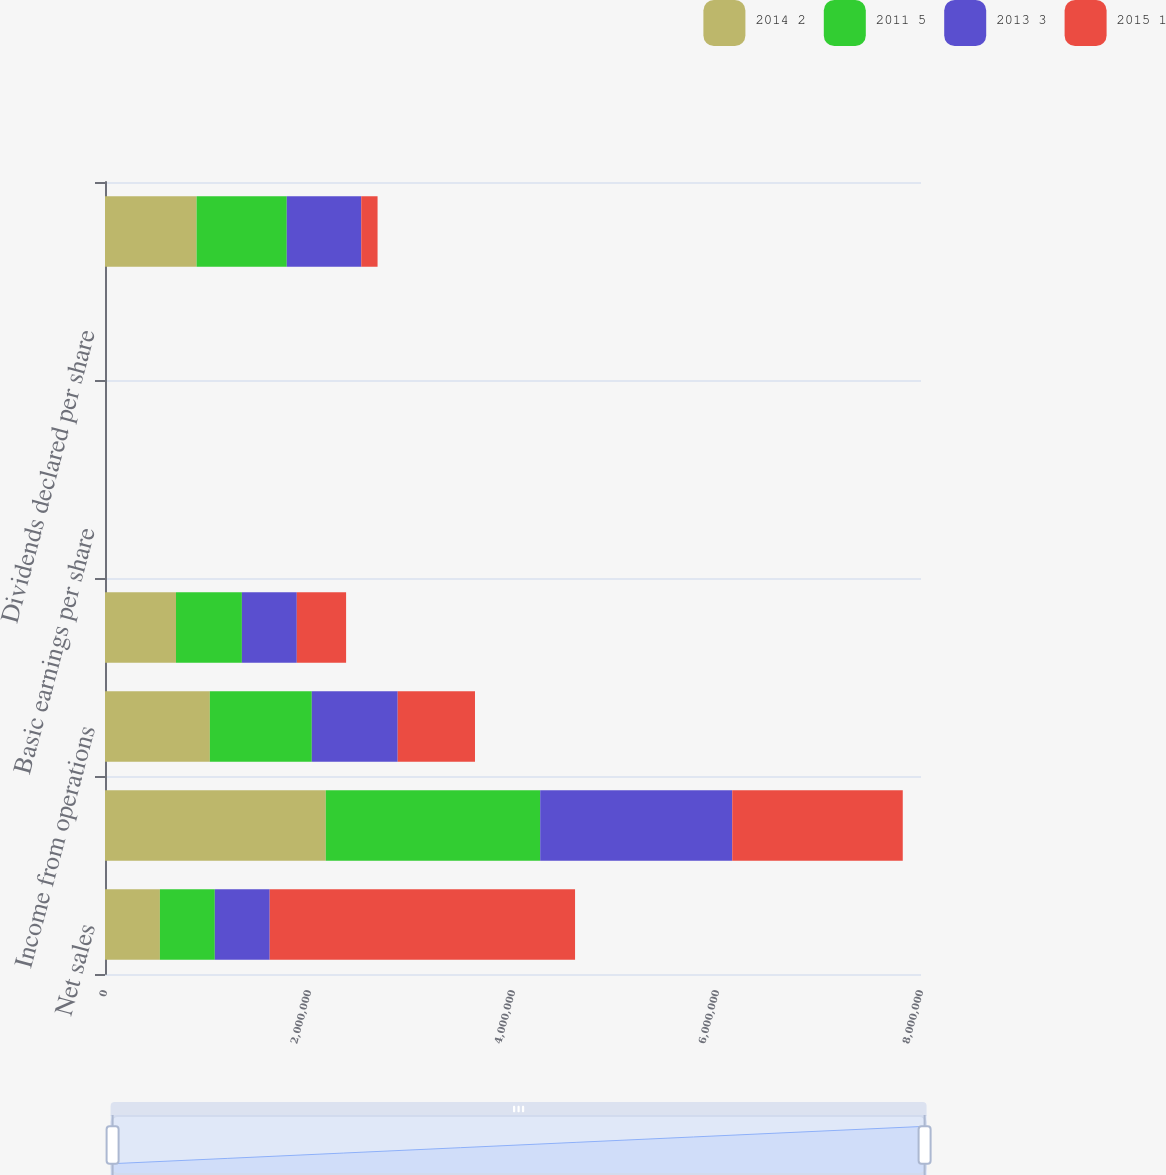Convert chart. <chart><loc_0><loc_0><loc_500><loc_500><stacked_bar_chart><ecel><fcel>Net sales<fcel>Gross profit<fcel>Income from operations<fcel>Net earnings<fcel>Basic earnings per share<fcel>Diluted earnings per share<fcel>Dividends declared per share<fcel>Working capital (6)<nl><fcel>2014 2<fcel>538293<fcel>2.16465e+06<fcel>1.02792e+06<fcel>696067<fcel>6.92<fcel>6.85<fcel>1.05<fcel>897919<nl><fcel>2011 5<fcel>538293<fcel>2.1019e+06<fcel>999473<fcel>646033<fcel>6.47<fcel>6.4<fcel>0.85<fcel>884158<nl><fcel>2013 3<fcel>538293<fcel>1.88293e+06<fcel>842361<fcel>538293<fcel>5.43<fcel>5.37<fcel>0.69<fcel>730246<nl><fcel>2015 1<fcel>2.99349e+06<fcel>1.67172e+06<fcel>757587<fcel>483360<fcel>4.95<fcel>4.86<fcel>0.58<fcel>159887<nl></chart> 